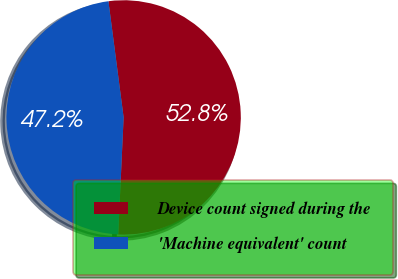Convert chart to OTSL. <chart><loc_0><loc_0><loc_500><loc_500><pie_chart><fcel>Device count signed during the<fcel>'Machine equivalent' count<nl><fcel>52.81%<fcel>47.19%<nl></chart> 